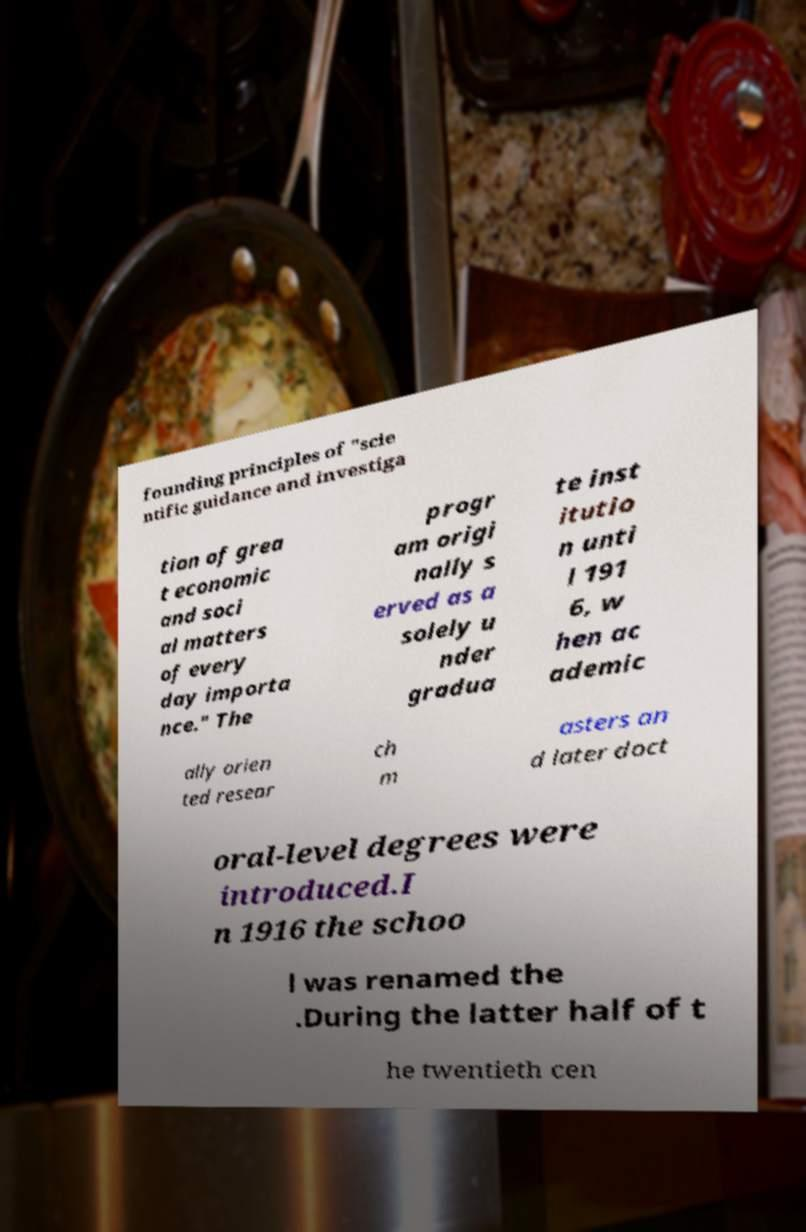Could you extract and type out the text from this image? founding principles of "scie ntific guidance and investiga tion of grea t economic and soci al matters of every day importa nce." The progr am origi nally s erved as a solely u nder gradua te inst itutio n unti l 191 6, w hen ac ademic ally orien ted resear ch m asters an d later doct oral-level degrees were introduced.I n 1916 the schoo l was renamed the .During the latter half of t he twentieth cen 